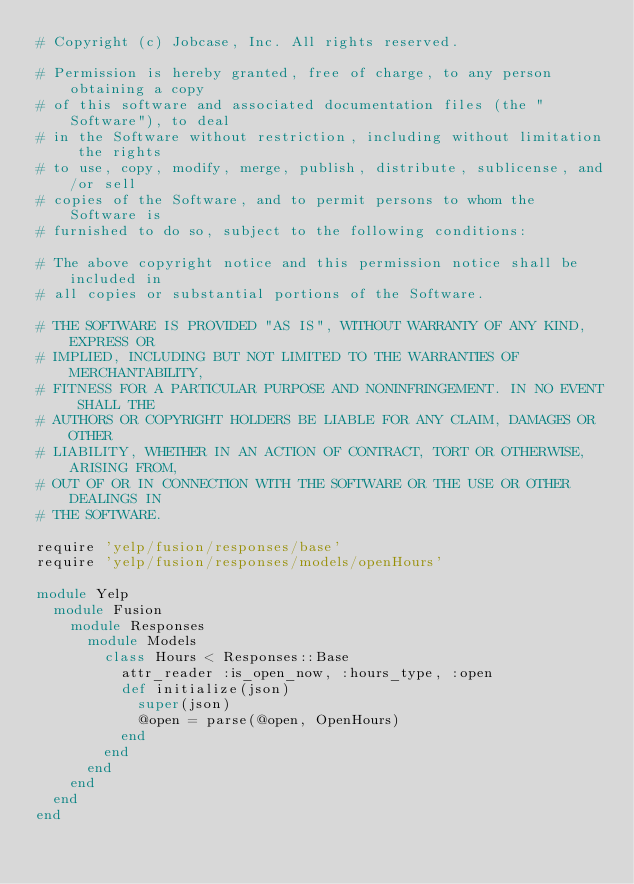Convert code to text. <code><loc_0><loc_0><loc_500><loc_500><_Ruby_># Copyright (c) Jobcase, Inc. All rights reserved.

# Permission is hereby granted, free of charge, to any person obtaining a copy
# of this software and associated documentation files (the "Software"), to deal
# in the Software without restriction, including without limitation the rights
# to use, copy, modify, merge, publish, distribute, sublicense, and/or sell
# copies of the Software, and to permit persons to whom the Software is
# furnished to do so, subject to the following conditions:

# The above copyright notice and this permission notice shall be included in
# all copies or substantial portions of the Software.

# THE SOFTWARE IS PROVIDED "AS IS", WITHOUT WARRANTY OF ANY KIND, EXPRESS OR
# IMPLIED, INCLUDING BUT NOT LIMITED TO THE WARRANTIES OF MERCHANTABILITY,
# FITNESS FOR A PARTICULAR PURPOSE AND NONINFRINGEMENT. IN NO EVENT SHALL THE
# AUTHORS OR COPYRIGHT HOLDERS BE LIABLE FOR ANY CLAIM, DAMAGES OR OTHER
# LIABILITY, WHETHER IN AN ACTION OF CONTRACT, TORT OR OTHERWISE, ARISING FROM,
# OUT OF OR IN CONNECTION WITH THE SOFTWARE OR THE USE OR OTHER DEALINGS IN
# THE SOFTWARE.

require 'yelp/fusion/responses/base'
require 'yelp/fusion/responses/models/openHours'

module Yelp
  module Fusion
    module Responses
      module Models
        class Hours < Responses::Base
          attr_reader :is_open_now, :hours_type, :open
          def initialize(json)
            super(json)
            @open = parse(@open, OpenHours)
          end
        end
      end
    end
  end
end</code> 